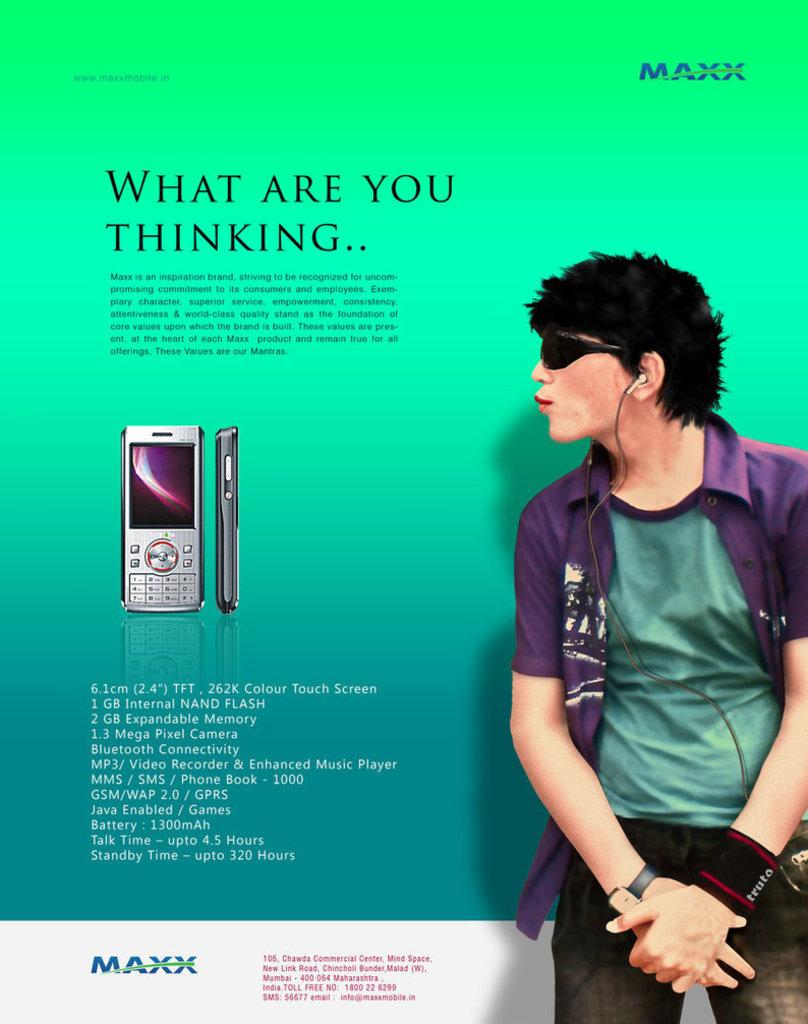Who is the main subject in the foreground of the poster? There is a man in the foreground of the poster. What is the man wearing in the poster? The man is wearing earphones in the poster. What can be seen to the right side of the man in the poster? There is text to the right side of the man in the poster. What type of electronic devices are depicted in the poster? Mobile phones are depicted in the poster. What brand or company might be represented by the logo in the poster? The presence of a logo in the poster suggests that a brand or company is being represented, but the specific identity cannot be determined from the facts provided. What type of weather can be seen in the poster with the clouds? There are no clouds visible in the poster, so it is not possible to determine the weather from the image. 